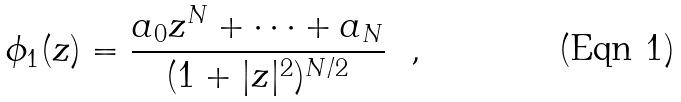<formula> <loc_0><loc_0><loc_500><loc_500>\phi _ { 1 } ( z ) = \frac { a _ { 0 } z ^ { N } + \cdots + a _ { N } } { ( 1 + | z | ^ { 2 } ) ^ { N / 2 } } \ \ ,</formula> 